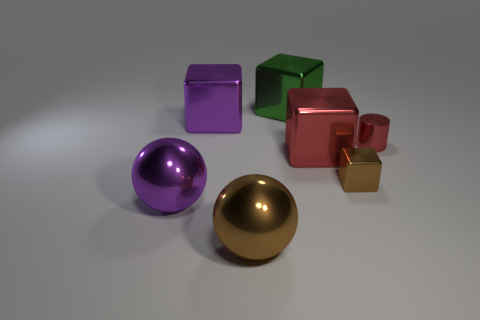What number of big purple shiny cylinders are there?
Your answer should be compact. 0. What material is the big purple object on the right side of the purple metal thing that is on the left side of the purple metallic thing behind the brown block?
Give a very brief answer. Metal. Is there a large brown object made of the same material as the big green cube?
Your answer should be compact. Yes. Is the material of the red cylinder the same as the large brown ball?
Give a very brief answer. Yes. What number of cylinders are either big purple metallic things or small brown shiny things?
Provide a succinct answer. 0. The tiny cube that is the same material as the big purple cube is what color?
Keep it short and to the point. Brown. Are there fewer big metal cylinders than small brown shiny things?
Your answer should be compact. Yes. Do the large purple object behind the small metal block and the shiny object in front of the purple metallic sphere have the same shape?
Your response must be concise. No. How many things are either small cubes or tiny red shiny cylinders?
Offer a terse response. 2. The other shiny sphere that is the same size as the brown shiny ball is what color?
Offer a terse response. Purple. 